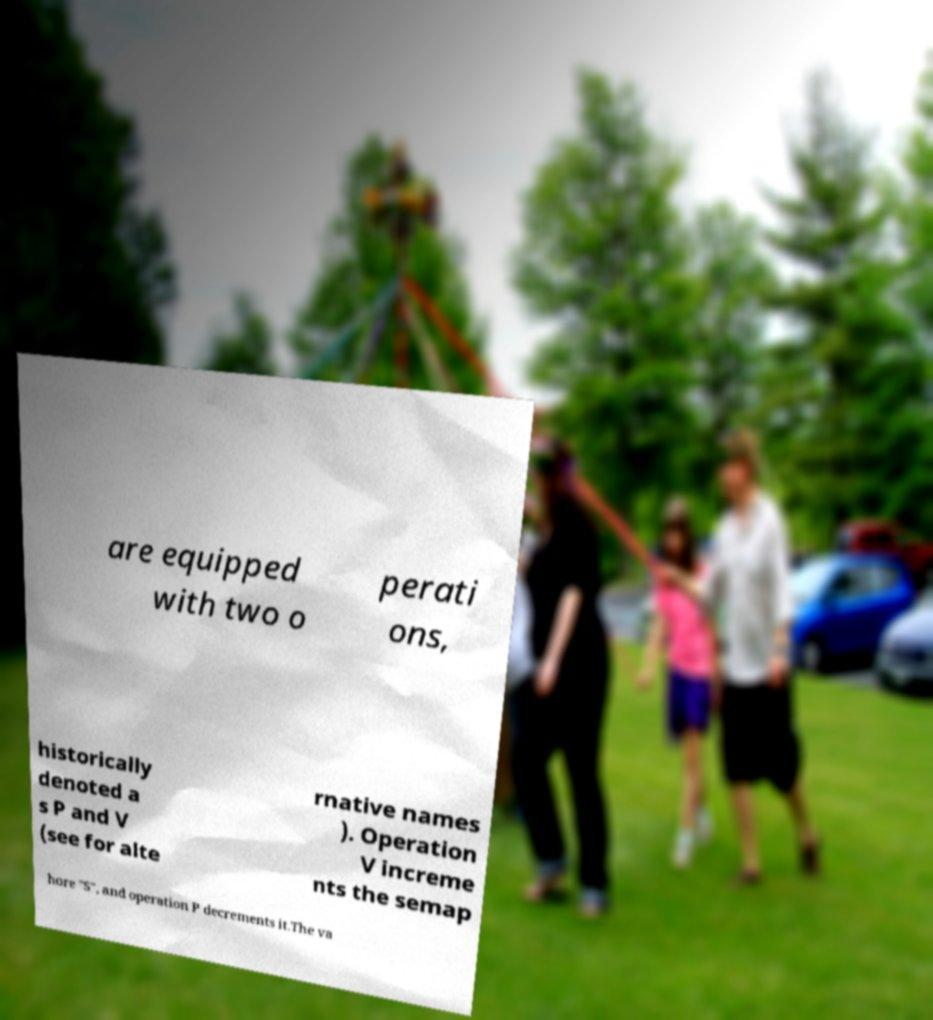There's text embedded in this image that I need extracted. Can you transcribe it verbatim? are equipped with two o perati ons, historically denoted a s P and V (see for alte rnative names ). Operation V increme nts the semap hore "S", and operation P decrements it.The va 